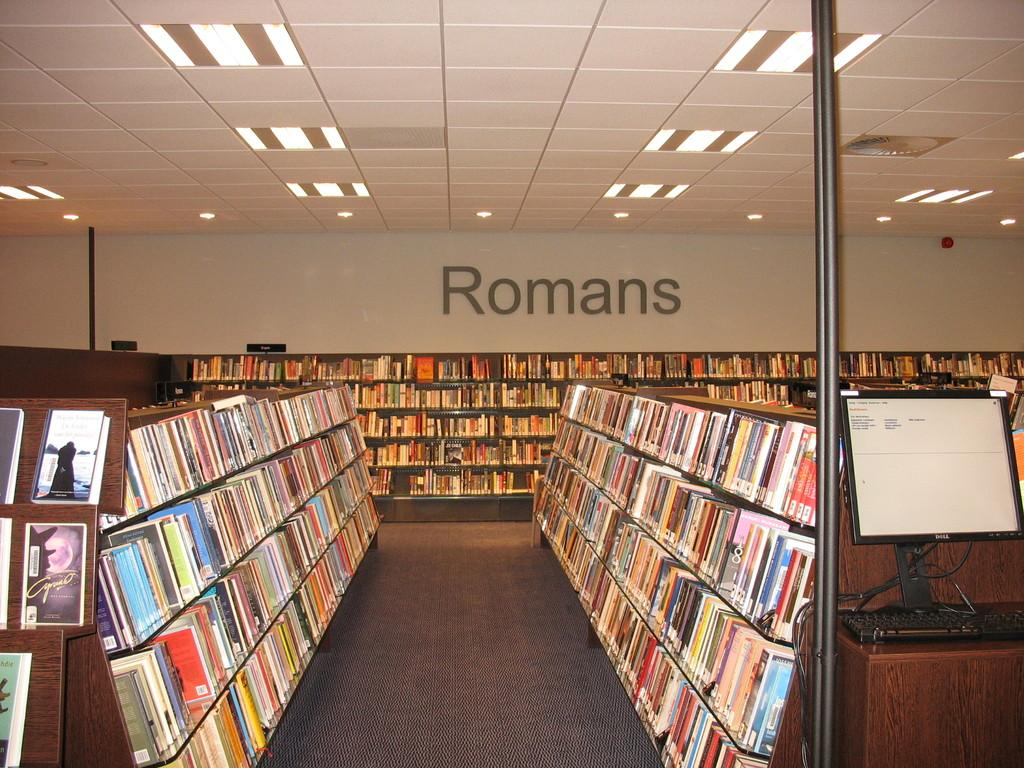<image>
Present a compact description of the photo's key features. The inside of a library, the Romans category is seen ahead. 